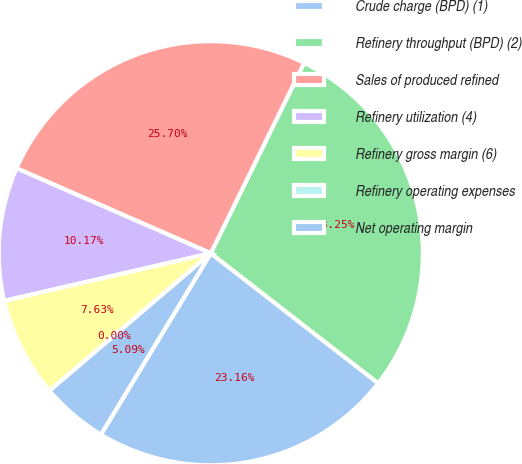Convert chart. <chart><loc_0><loc_0><loc_500><loc_500><pie_chart><fcel>Crude charge (BPD) (1)<fcel>Refinery throughput (BPD) (2)<fcel>Sales of produced refined<fcel>Refinery utilization (4)<fcel>Refinery gross margin (6)<fcel>Refinery operating expenses<fcel>Net operating margin<nl><fcel>23.16%<fcel>28.25%<fcel>25.7%<fcel>10.17%<fcel>7.63%<fcel>0.0%<fcel>5.09%<nl></chart> 